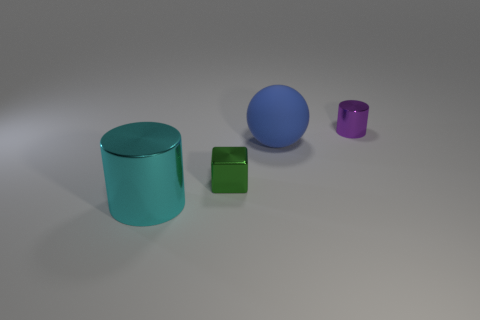Add 3 tiny gray metallic cubes. How many objects exist? 7 Add 3 large yellow blocks. How many large yellow blocks exist? 3 Subtract 1 blue balls. How many objects are left? 3 Subtract all balls. How many objects are left? 3 Subtract all big cyan objects. Subtract all large gray spheres. How many objects are left? 3 Add 4 large cylinders. How many large cylinders are left? 5 